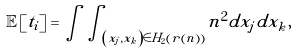<formula> <loc_0><loc_0><loc_500><loc_500>\mathbb { E } \left [ t _ { i } \right ] = \int \int _ { \left ( x _ { j } , x _ { k } \right ) \in H _ { 2 } \left ( r \left ( n \right ) \right ) } n ^ { 2 } d x _ { j } d x _ { k } ,</formula> 